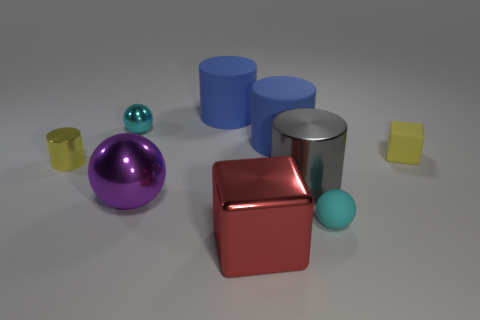Subtract all small metallic cylinders. How many cylinders are left? 3 Subtract 2 spheres. How many spheres are left? 1 Subtract all gray balls. How many blue cylinders are left? 2 Subtract all spheres. How many objects are left? 6 Subtract all purple balls. How many balls are left? 2 Subtract all purple cylinders. Subtract all red spheres. How many cylinders are left? 4 Subtract all big purple blocks. Subtract all big shiny cylinders. How many objects are left? 8 Add 8 large red cubes. How many large red cubes are left? 9 Add 2 big purple spheres. How many big purple spheres exist? 3 Subtract 0 green blocks. How many objects are left? 9 